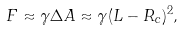<formula> <loc_0><loc_0><loc_500><loc_500>F \approx \gamma \Delta A \approx \gamma ( L - R _ { c } ) ^ { 2 } ,</formula> 